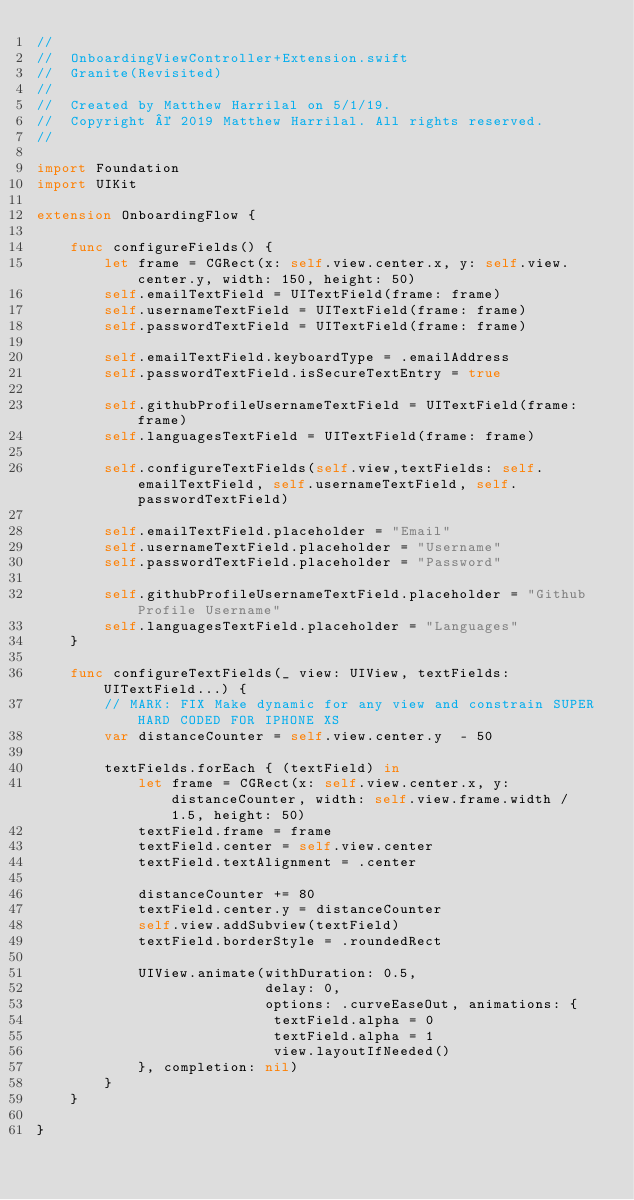Convert code to text. <code><loc_0><loc_0><loc_500><loc_500><_Swift_>//
//  OnboardingViewController+Extension.swift
//  Granite(Revisited)
//
//  Created by Matthew Harrilal on 5/1/19.
//  Copyright © 2019 Matthew Harrilal. All rights reserved.
//

import Foundation
import UIKit

extension OnboardingFlow {
    
    func configureFields() {
        let frame = CGRect(x: self.view.center.x, y: self.view.center.y, width: 150, height: 50)
        self.emailTextField = UITextField(frame: frame)
        self.usernameTextField = UITextField(frame: frame)
        self.passwordTextField = UITextField(frame: frame)
        
        self.emailTextField.keyboardType = .emailAddress
        self.passwordTextField.isSecureTextEntry = true
        
        self.githubProfileUsernameTextField = UITextField(frame: frame)
        self.languagesTextField = UITextField(frame: frame)
        
        self.configureTextFields(self.view,textFields: self.emailTextField, self.usernameTextField, self.passwordTextField)
        
        self.emailTextField.placeholder = "Email"
        self.usernameTextField.placeholder = "Username"
        self.passwordTextField.placeholder = "Password"
        
        self.githubProfileUsernameTextField.placeholder = "Github Profile Username"
        self.languagesTextField.placeholder = "Languages"
    }
    
    func configureTextFields(_ view: UIView, textFields: UITextField...) {
        // MARK: FIX Make dynamic for any view and constrain SUPER HARD CODED FOR IPHONE XS
        var distanceCounter = self.view.center.y  - 50
        
        textFields.forEach { (textField) in
            let frame = CGRect(x: self.view.center.x, y: distanceCounter, width: self.view.frame.width / 1.5, height: 50)
            textField.frame = frame
            textField.center = self.view.center
            textField.textAlignment = .center
            
            distanceCounter += 80
            textField.center.y = distanceCounter
            self.view.addSubview(textField)
            textField.borderStyle = .roundedRect
            
            UIView.animate(withDuration: 0.5,
                           delay: 0,
                           options: .curveEaseOut, animations: {
                            textField.alpha = 0
                            textField.alpha = 1
                            view.layoutIfNeeded()
            }, completion: nil)
        }
    }
    
}
</code> 